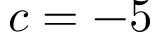Convert formula to latex. <formula><loc_0><loc_0><loc_500><loc_500>c = - 5</formula> 